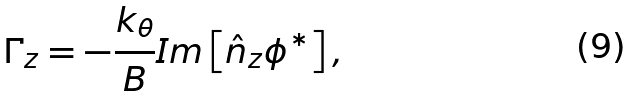Convert formula to latex. <formula><loc_0><loc_0><loc_500><loc_500>\Gamma _ { z } = - \frac { k _ { \theta } } { B } I m \left [ \hat { n } _ { z } \phi ^ { \ast } \right ] ,</formula> 